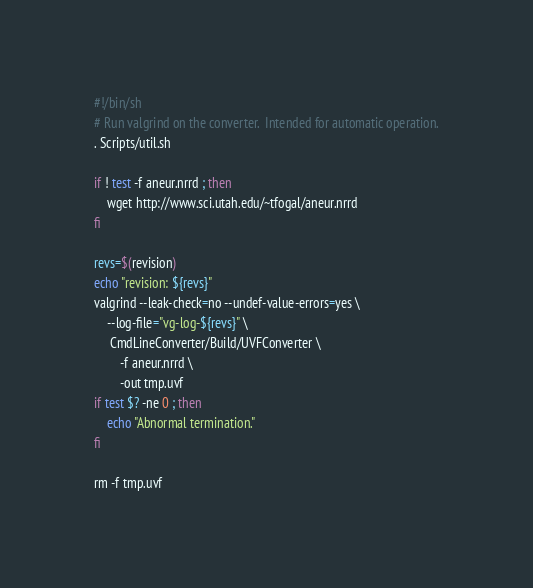<code> <loc_0><loc_0><loc_500><loc_500><_Bash_>#!/bin/sh
# Run valgrind on the converter.  Intended for automatic operation.
. Scripts/util.sh

if ! test -f aneur.nrrd ; then
    wget http://www.sci.utah.edu/~tfogal/aneur.nrrd
fi

revs=$(revision)
echo "revision: ${revs}"
valgrind --leak-check=no --undef-value-errors=yes \
    --log-file="vg-log-${revs}" \
     CmdLineConverter/Build/UVFConverter \
        -f aneur.nrrd \
        -out tmp.uvf
if test $? -ne 0 ; then
    echo "Abnormal termination."
fi

rm -f tmp.uvf
</code> 